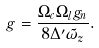<formula> <loc_0><loc_0><loc_500><loc_500>g = \frac { \Omega _ { c } \Omega _ { l } g _ { n } } { 8 \Delta ^ { \prime } \tilde { \omega } _ { z } } .</formula> 